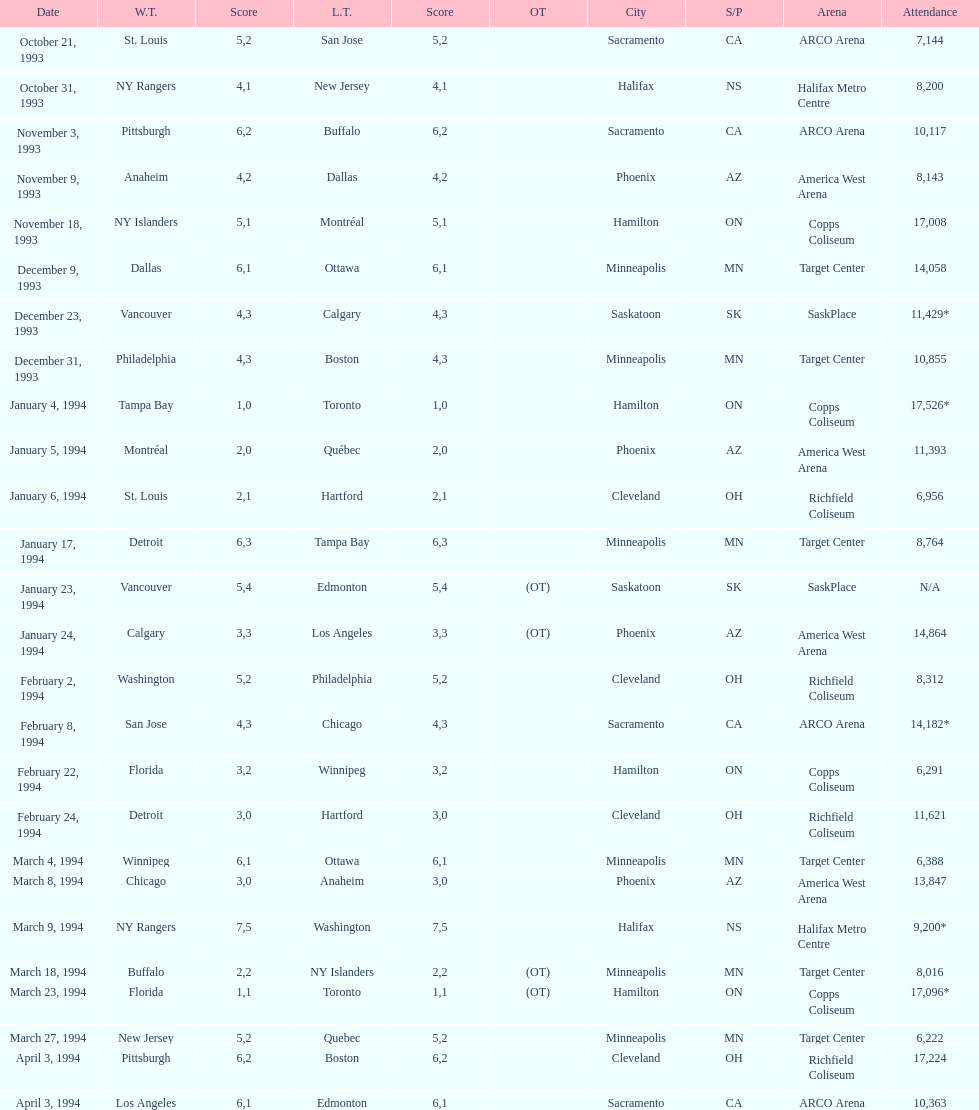How many neutral venue matches ended in overtime (ot)? 4. 